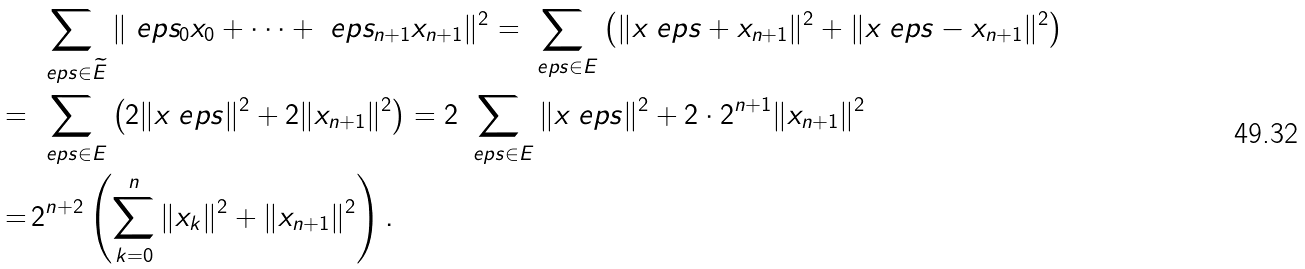<formula> <loc_0><loc_0><loc_500><loc_500>& \sum _ { \ e p s \in \widetilde { E } } \| \ e p s _ { 0 } x _ { 0 } + \cdots + \ e p s _ { n + 1 } x _ { n + 1 } \| ^ { 2 } = \sum _ { \ e p s \in E } \left ( \| x _ { \ } e p s + x _ { n + 1 } \| ^ { 2 } + \| x _ { \ } e p s - x _ { n + 1 } \| ^ { 2 } \right ) \\ = \, & \sum _ { \ e p s \in E } \left ( 2 \| x _ { \ } e p s \| ^ { 2 } + 2 \| x _ { n + 1 } \| ^ { 2 } \right ) = 2 \sum _ { \ e p s \in E } \| x _ { \ } e p s \| ^ { 2 } + 2 \cdot 2 ^ { n + 1 } \| x _ { n + 1 } \| ^ { 2 } \\ = \, & 2 ^ { n + 2 } \left ( \sum _ { k = 0 } ^ { n } \| x _ { k } \| ^ { 2 } + \| x _ { n + 1 } \| ^ { 2 } \right ) .</formula> 